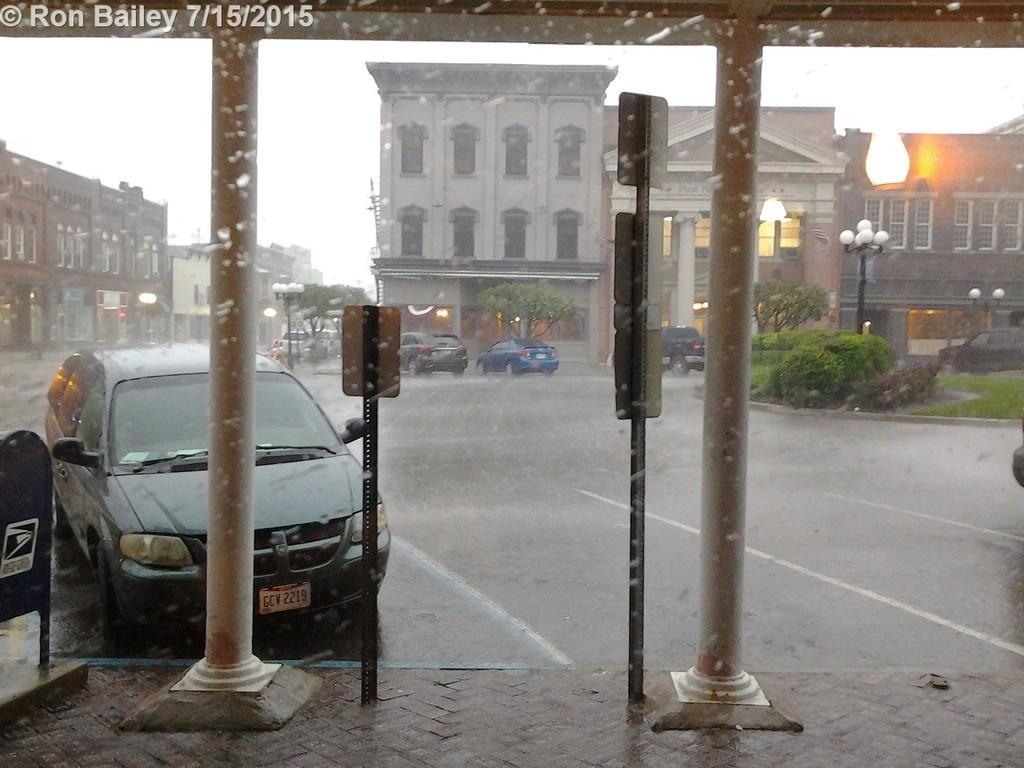Could you give a brief overview of what you see in this image? In the foreground of this picture, there are two pillars and poles at front. In the background, there are cars moving on the road while raining and there are buildings, poles, trees, lights and the sky. 